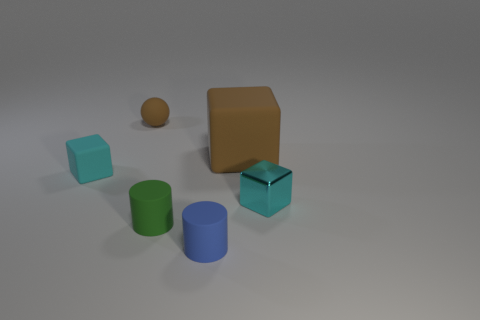Are there any green things that have the same shape as the blue matte object?
Your response must be concise. Yes. There is a big rubber thing behind the tiny blue rubber cylinder; does it have the same shape as the tiny green matte thing?
Provide a succinct answer. No. How many things are behind the blue cylinder and in front of the small green object?
Offer a terse response. 0. What shape is the brown thing on the left side of the tiny blue cylinder?
Your response must be concise. Sphere. What number of cyan blocks are the same material as the green cylinder?
Offer a very short reply. 1. There is a tiny cyan rubber object; is its shape the same as the small blue object in front of the brown ball?
Make the answer very short. No. There is a cyan object on the left side of the brown matte object to the right of the rubber ball; are there any cyan things that are left of it?
Offer a terse response. No. What is the size of the brown rubber thing that is on the left side of the small green rubber cylinder?
Provide a succinct answer. Small. What is the material of the green thing that is the same size as the shiny block?
Your answer should be compact. Rubber. Do the tiny blue object and the tiny cyan shiny object have the same shape?
Give a very brief answer. No. 